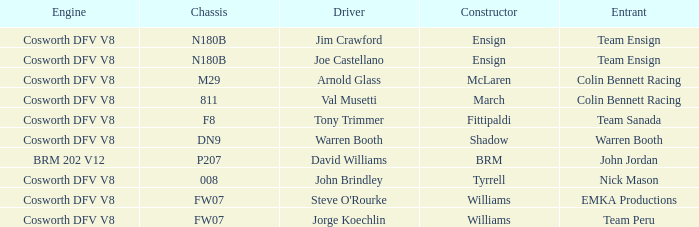What group operated the vehicle manufactured by brm? John Jordan. 